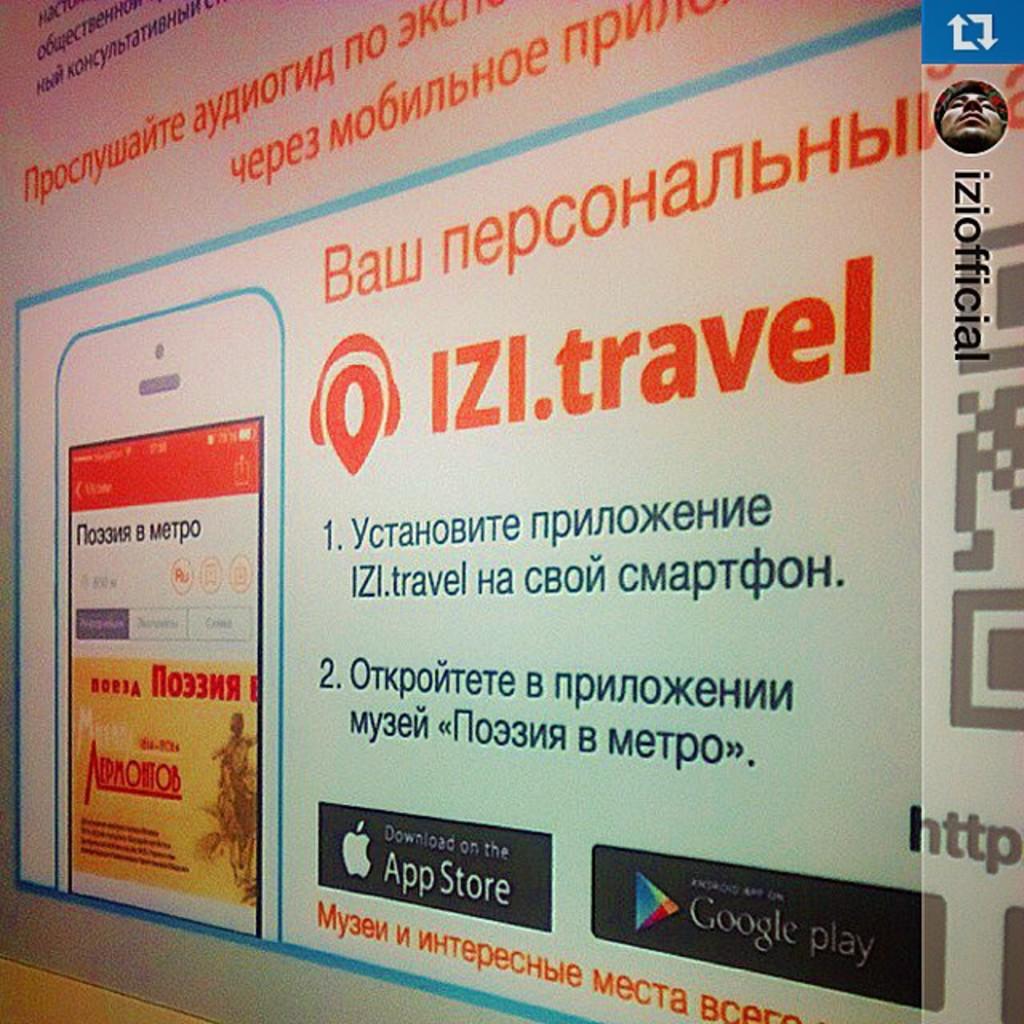Which store can the application be downloaded on?
Give a very brief answer. App store. What are the three letters before the word travel on the wall?
Offer a very short reply. Izi. 